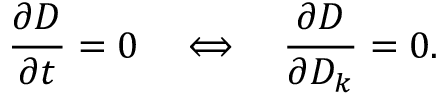<formula> <loc_0><loc_0><loc_500><loc_500>\frac { \partial D } { \partial t } = 0 \quad \Longleftrightarrow \quad \frac { \partial D } { \partial D _ { k } } = 0 .</formula> 